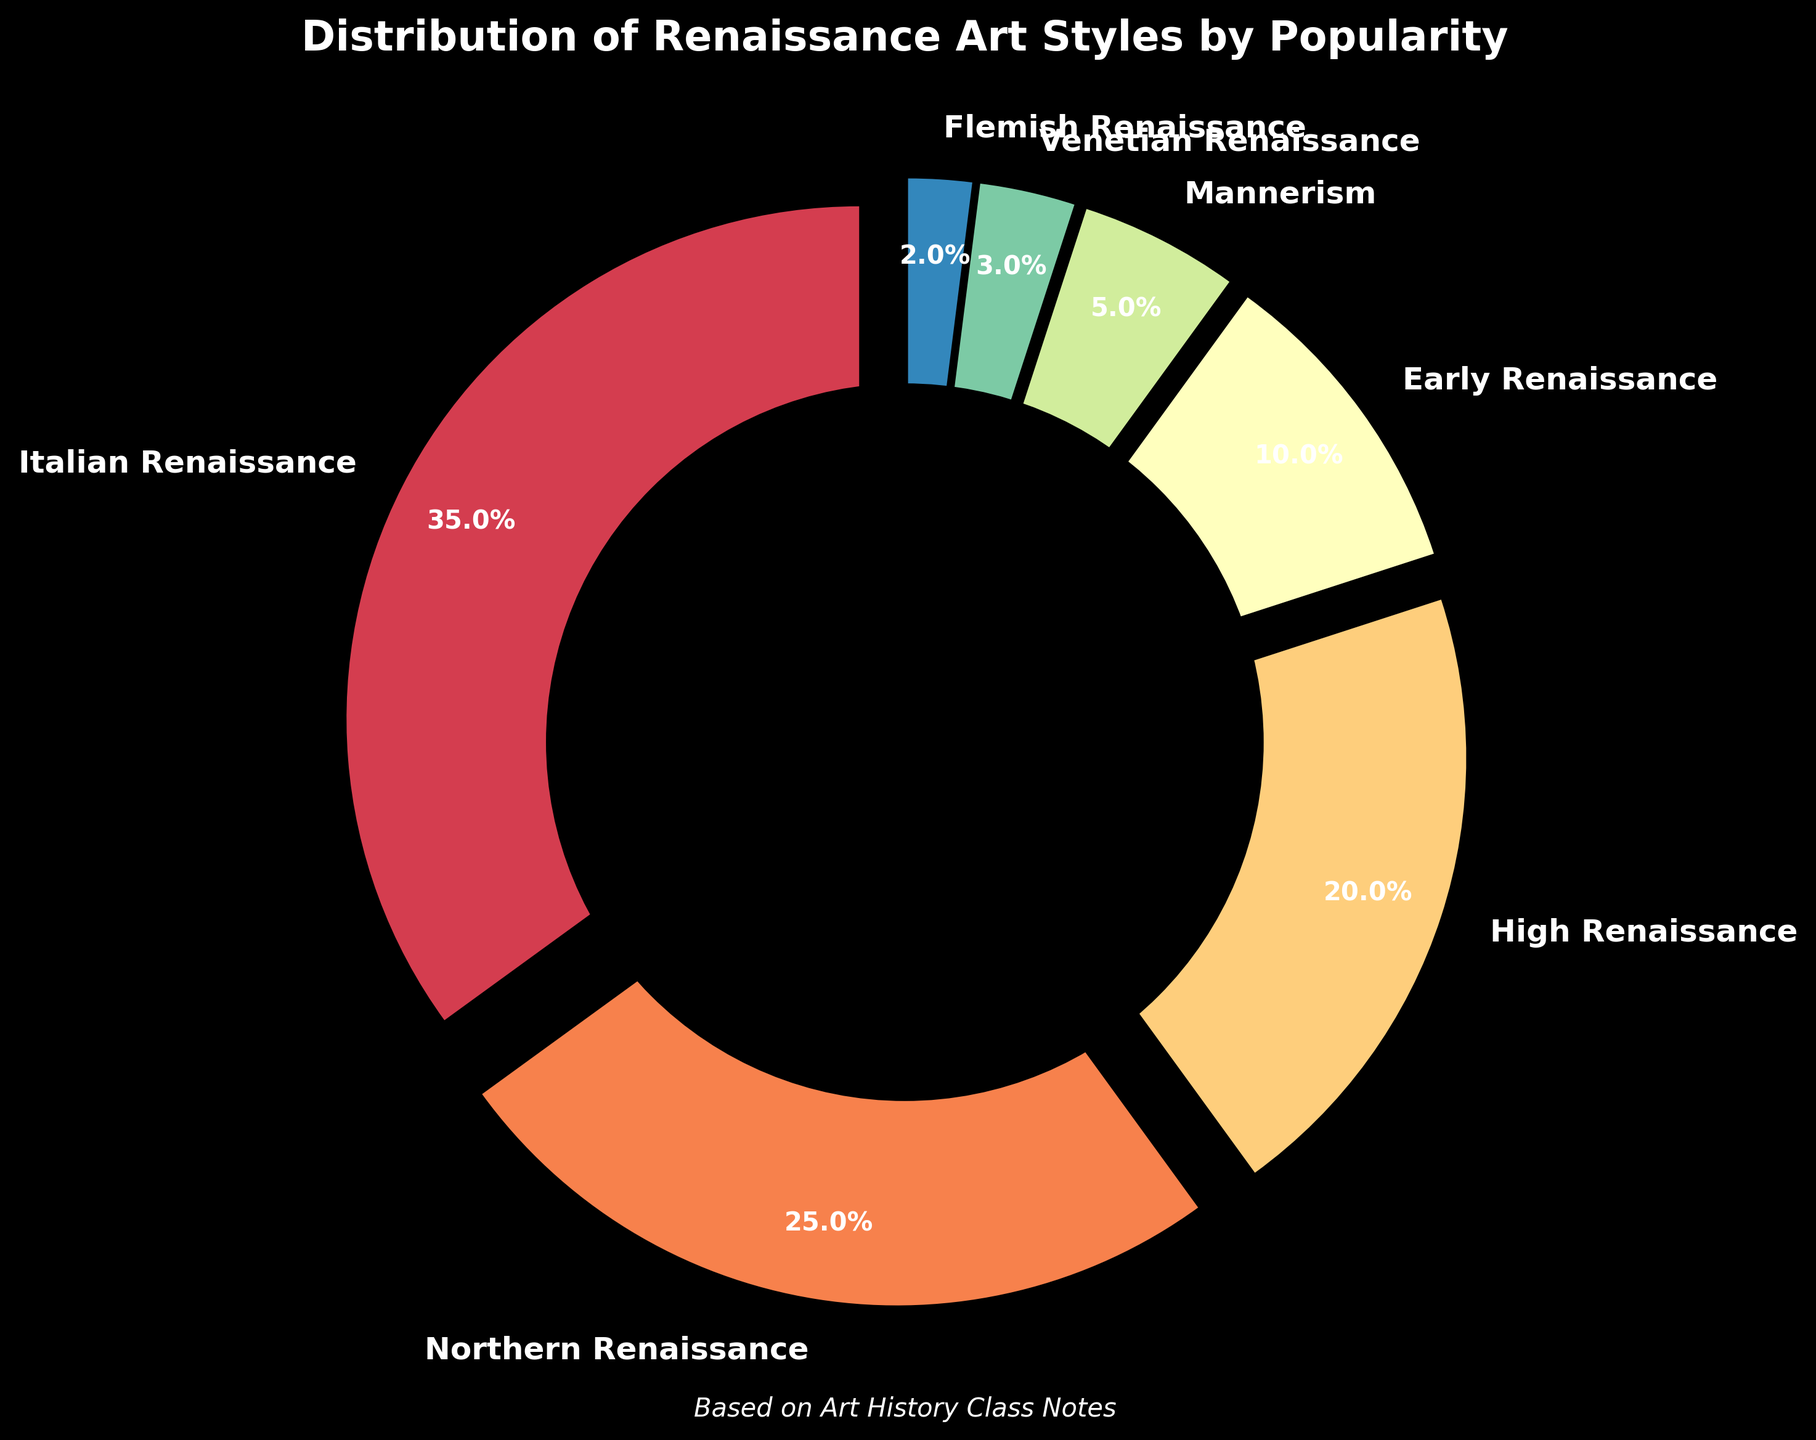Which Renaissance art style is the most popular? The pie chart shows the distribution by percentage. The largest slice represents the Italian Renaissance at 35%, making it the most popular.
Answer: Italian Renaissance What is the combined popularity percentage of the Early Renaissance and Mannerism styles? To find the combined popularity, add the percentages of the Early Renaissance and Mannerism: 10% + 5% = 15%.
Answer: 15% Which two art styles together make up less than 10% of the total popularity? The slices for Venetian Renaissance and Flemish Renaissance represent 3% and 2% respectively. When combined, they total 5%, which is less than 10%.
Answer: Venetian Renaissance and Flemish Renaissance How does the popularity of the Northern Renaissance compare to the High Renaissance? The pie chart shows the Northern Renaissance has 25%, while the High Renaissance has 20%. Therefore, the Northern Renaissance is 5% more popular than the High Renaissance.
Answer: Northern Renaissance is 5% more popular Which art style has the smallest segment in the pie chart, and what is its percentage? The smallest segment in the pie chart is for the Flemish Renaissance, which has a popularity percentage of 2%.
Answer: Flemish Renaissance, 2% What is the visual cue used to differentiate the slices in the pie chart? The pie chart uses different colors for each slice to differentiate the various Renaissance art styles. Each slice is also slightly exploded to stand out individually.
Answer: Different colors and slight explosion If two art styles have a total popularity of 50%, which styles are they? Examining the pie chart, the Italian Renaissance and Northern Renaissance have 35% and 25%, respectively. Together, they total 60%, which is the closest pair to 50% without exceeding.
Answer: There are no exact two styles totaling 50% What is the ratio of the popularity of the High Renaissance to the Venetian Renaissance? The pie chart shows the High Renaissance with 20% and the Venetian Renaissance with 3%. The ratio is 20:3 when simplified.
Answer: 20:3 If you add the popularity percentages of the least three popular art styles, what do you get? The least three popular art styles are Venetian Renaissance (3%), Flemish Renaissance (2%), and Mannerism (5%). Adding them gives 3% + 2% + 5% = 10%.
Answer: 10% Does any art style make up exactly one-third of the total popularity? The pie chart shows that the Italian Renaissance has 35%, which is slightly more than one-third (33.33%). Therefore, no style is exactly one-third of the total.
Answer: No 